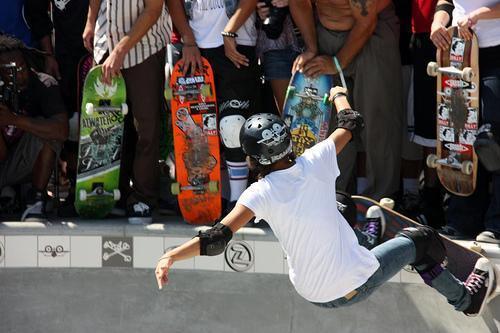How many skateboards are present?
Give a very brief answer. 5. How many skateboards can you see?
Give a very brief answer. 5. How many people are in the photo?
Give a very brief answer. 9. How many elephants are adults?
Give a very brief answer. 0. 